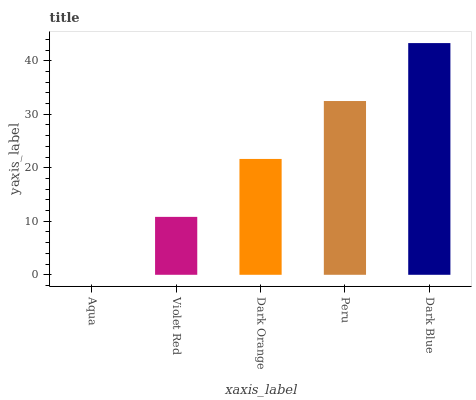Is Aqua the minimum?
Answer yes or no. Yes. Is Dark Blue the maximum?
Answer yes or no. Yes. Is Violet Red the minimum?
Answer yes or no. No. Is Violet Red the maximum?
Answer yes or no. No. Is Violet Red greater than Aqua?
Answer yes or no. Yes. Is Aqua less than Violet Red?
Answer yes or no. Yes. Is Aqua greater than Violet Red?
Answer yes or no. No. Is Violet Red less than Aqua?
Answer yes or no. No. Is Dark Orange the high median?
Answer yes or no. Yes. Is Dark Orange the low median?
Answer yes or no. Yes. Is Dark Blue the high median?
Answer yes or no. No. Is Peru the low median?
Answer yes or no. No. 